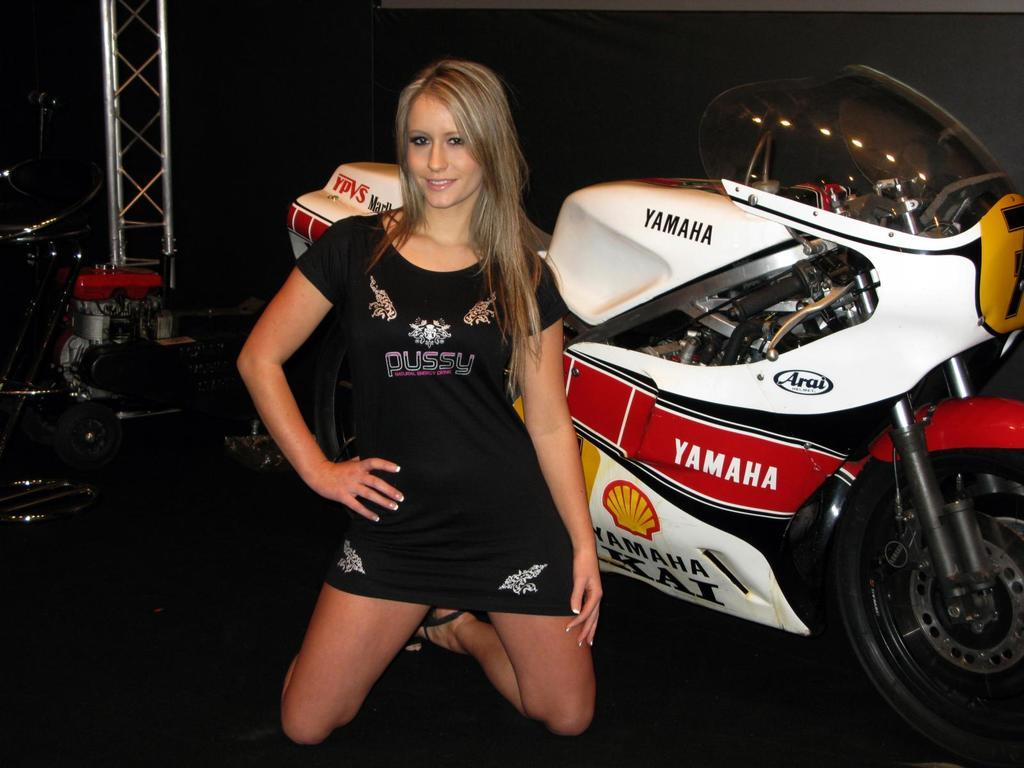Who is present in the image? There is a woman in the image. What is the woman doing in the image? The woman is smiling in the image. What vehicle can be seen in the image? There is a motorbike in the image. What is the large structure in the image? There is a lighting truss in the image. What else can be seen in the background of the image? There are other objects in the background of the image. What type of meal is being prepared on the motorbike in the image? There is no meal being prepared on the motorbike in the image; it is a vehicle, not a cooking surface. 